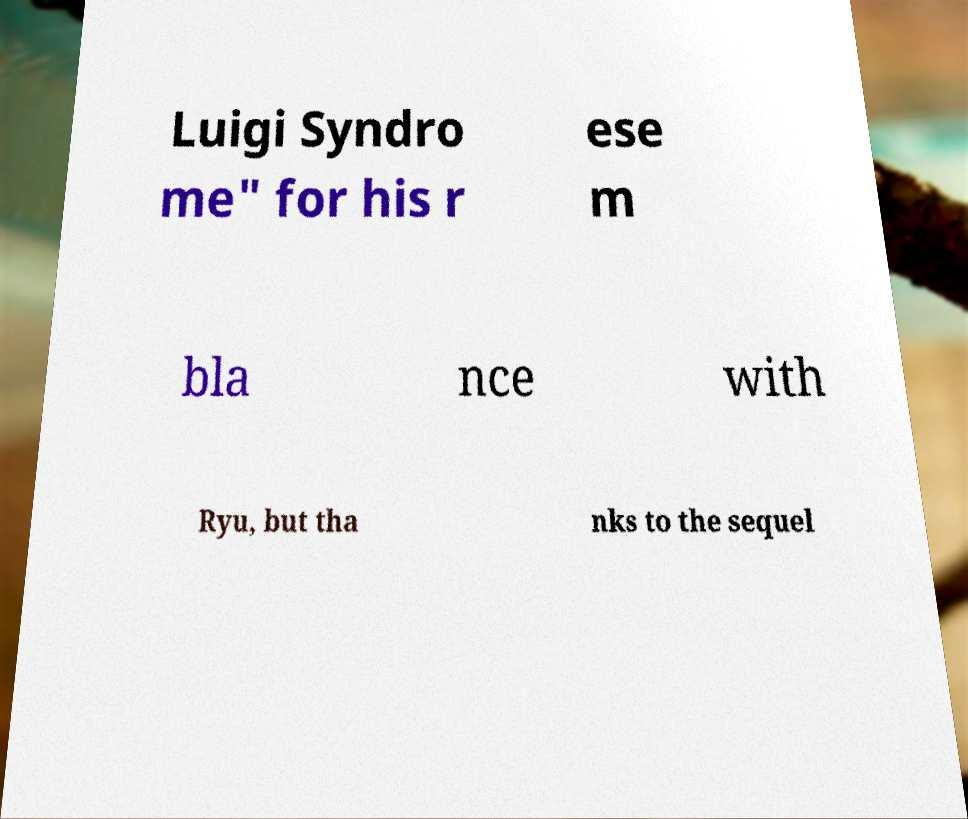Please identify and transcribe the text found in this image. Luigi Syndro me" for his r ese m bla nce with Ryu, but tha nks to the sequel 